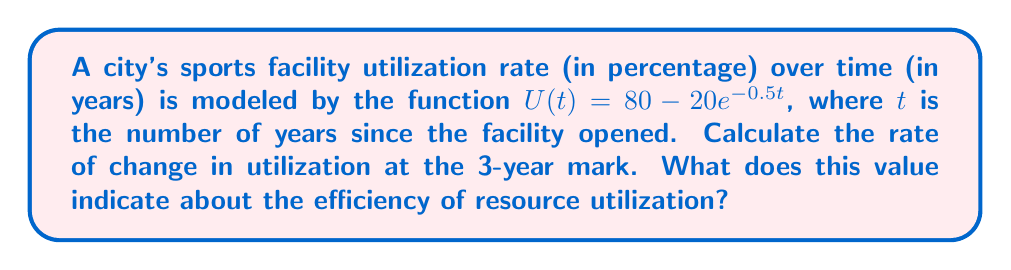Solve this math problem. To solve this problem, we need to find the derivative of the function $U(t)$ and evaluate it at $t=3$. Here's the step-by-step process:

1) The given function is $U(t) = 80 - 20e^{-0.5t}$

2) To find the derivative, we use the chain rule:
   $$\frac{dU}{dt} = 0 - 20 \cdot (-0.5) \cdot e^{-0.5t}$$

3) Simplify:
   $$\frac{dU}{dt} = 10e^{-0.5t}$$

4) Now, we evaluate this at $t=3$:
   $$\frac{dU}{dt}\bigg|_{t=3} = 10e^{-0.5(3)}$$

5) Calculate:
   $$\frac{dU}{dt}\bigg|_{t=3} = 10e^{-1.5} \approx 2.24$$

This value (2.24) represents the instantaneous rate of change in the utilization rate at the 3-year mark. It indicates that the utilization rate is increasing by approximately 2.24 percentage points per year at this time. 

For a sports policy advisor, this positive rate of change suggests that the efficiency of resource utilization in the sports facility is improving over time, albeit at a decreasing rate (since the derivative is positive but decreasing due to the negative exponent). This information can be valuable for assessing the success of current policies and planning future investments in sports facilities.
Answer: $10e^{-1.5} \approx 2.24$ percentage points per year 